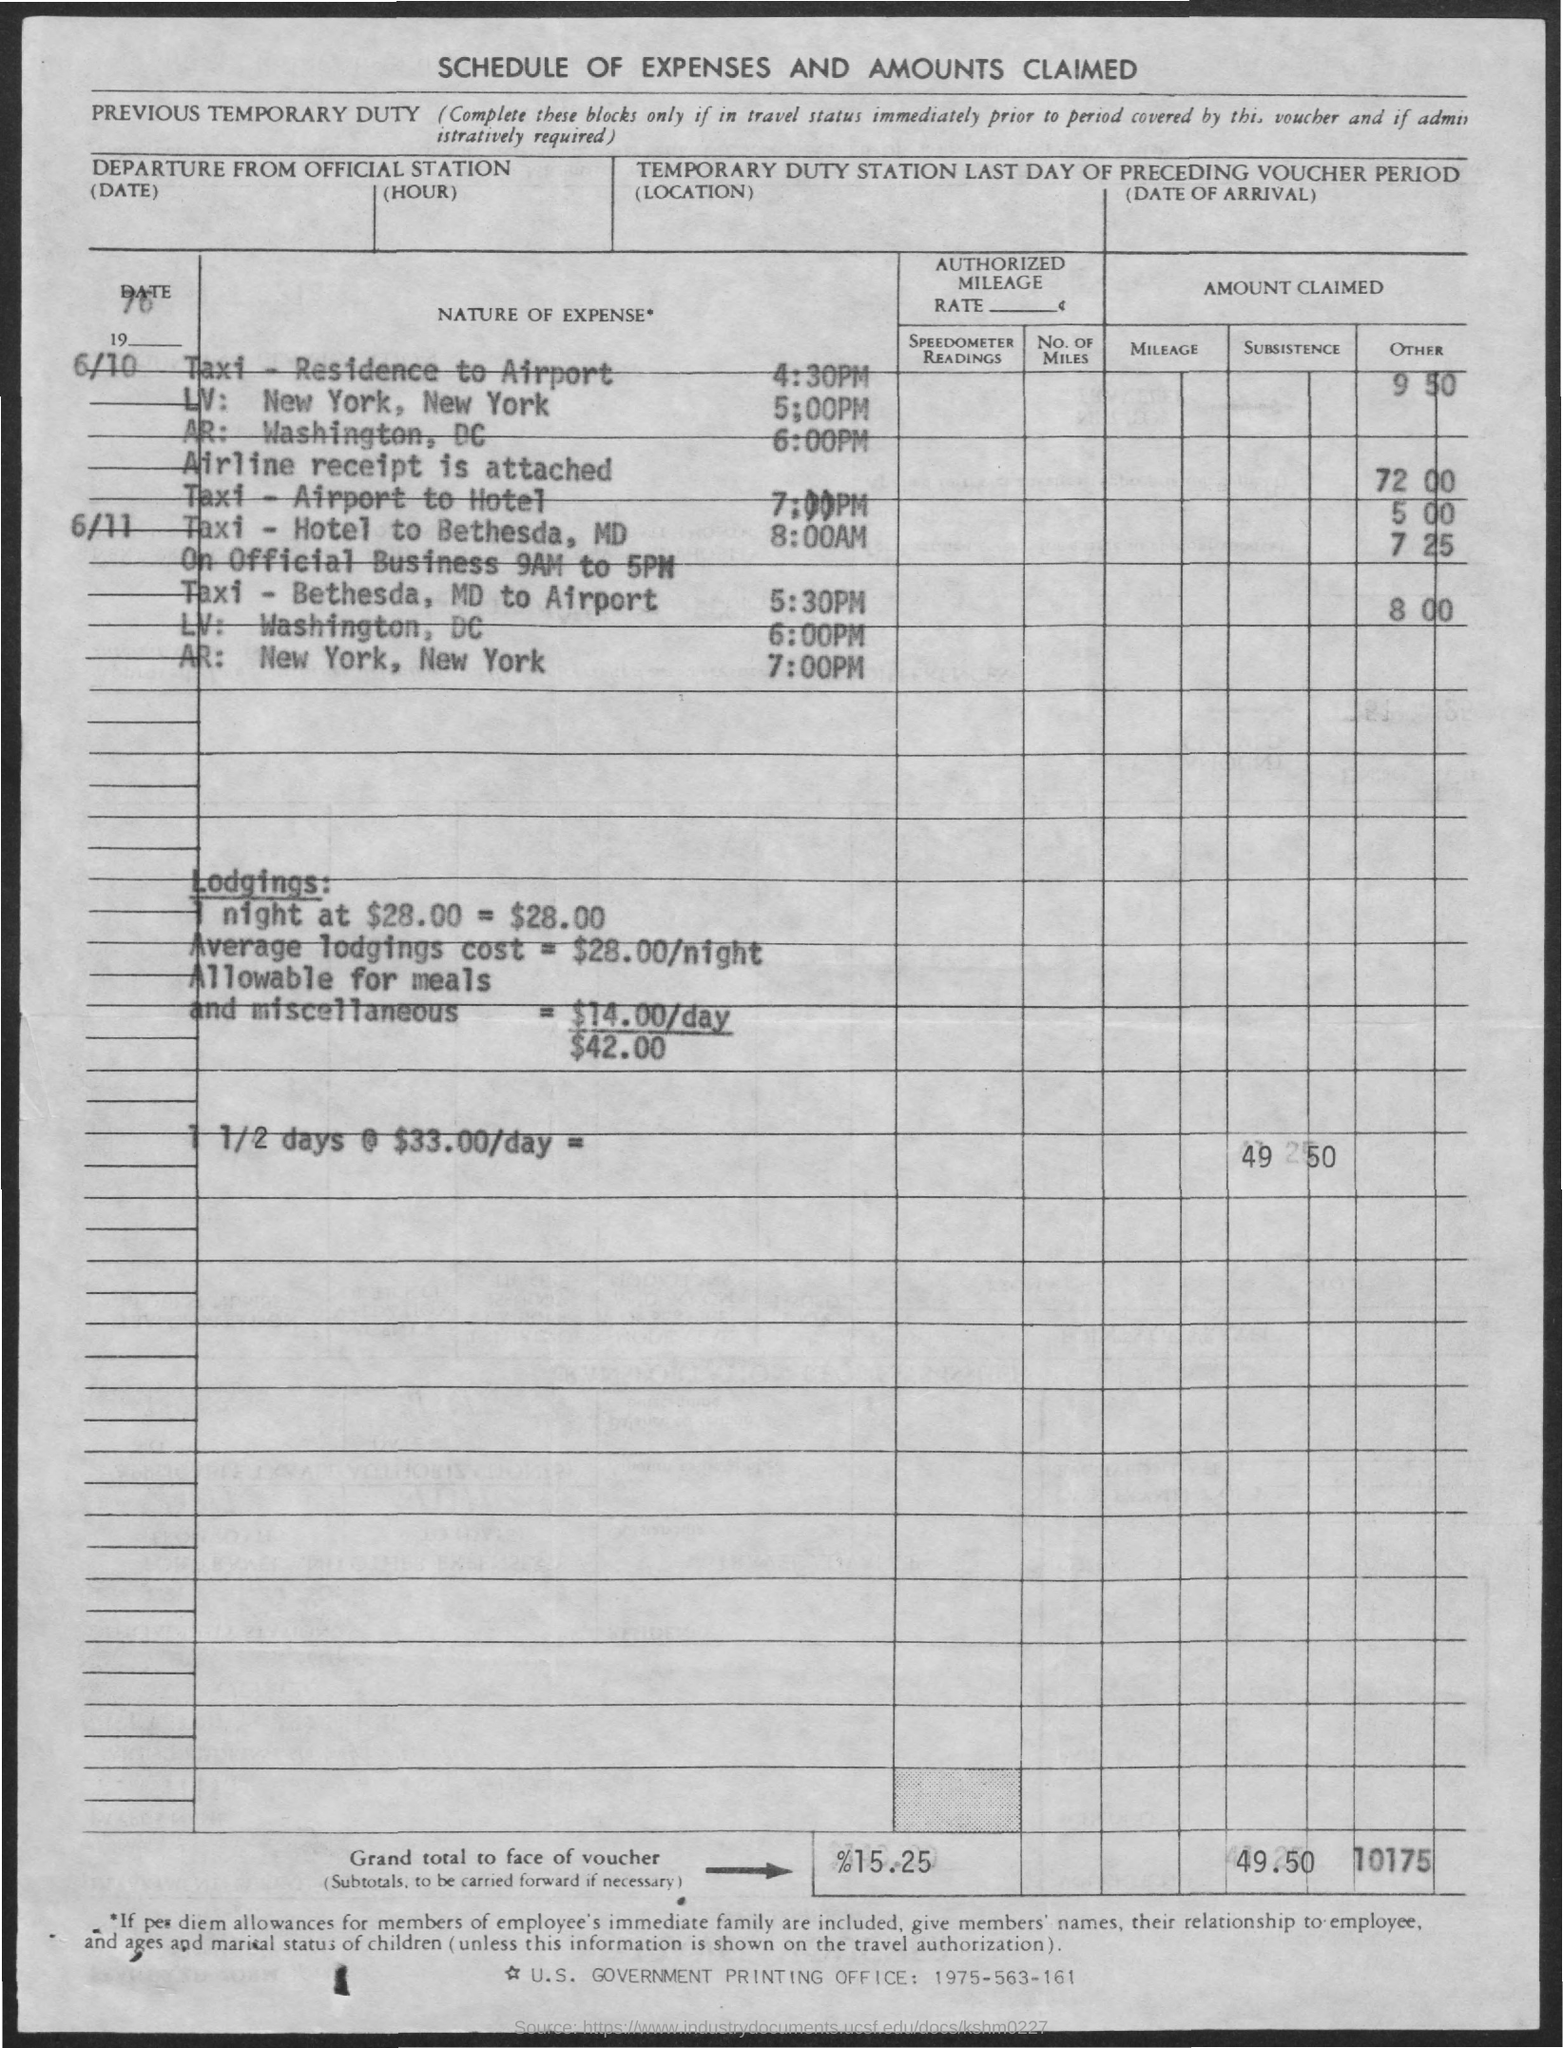List a handful of essential elements in this visual. What is the title of the document that provides a schedule of expenses and the amounts claimed? 